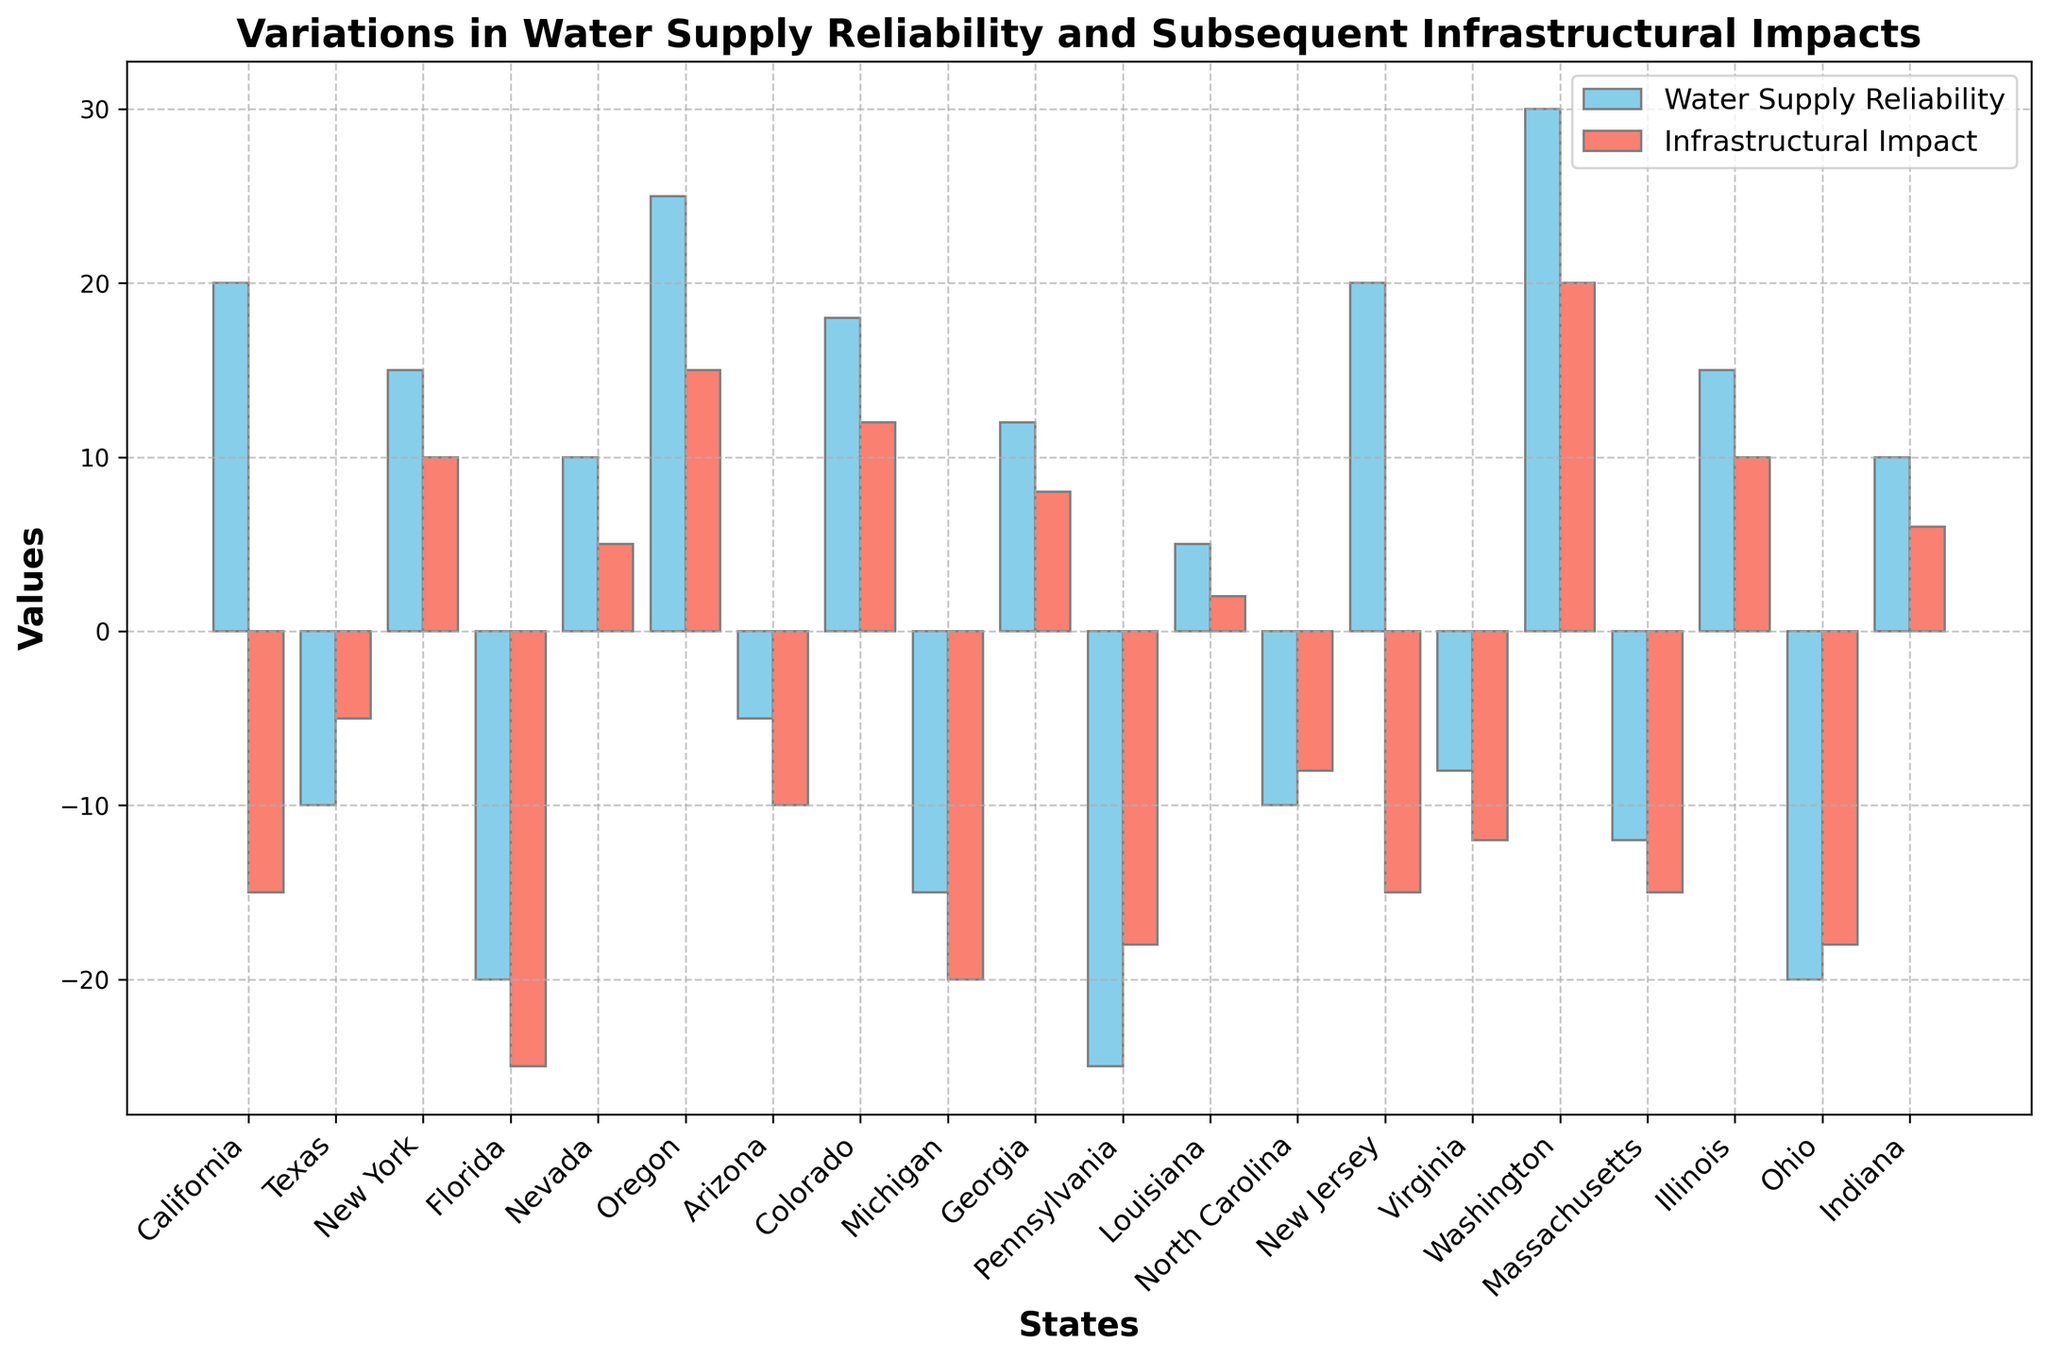What's the state with the highest positive water supply reliability? By visually inspecting the heights of the sky-blue bars, we see that Washington has the tallest positive bar, indicating the highest positive water supply reliability.
Answer: Washington Which two states have identical infrastructural impacts? By examining the heights and lengths of the salmon-colored bars, we notice that California and New Jersey both have identical values of -15.
Answer: California and New Jersey Compare the water supply reliability of Texas and Oregon. Which state has better reliability? Observing the sky-blue bars for Texas and Oregon, Texas' bar is below the baseline (negative value), whereas Oregon's bar is substantially above the baseline. Thus, Oregon has better reliability.
Answer: Oregon What is the difference in water supply reliability between Arizona and Michigan? Arizona's water supply reliability is -5 (below the baseline by 5 units), and Michigan's is -15 (below the baseline by 15 units). The difference is calculated as -5 - (-15), resulting in 10 units.
Answer: 10 units Which state has the worst infrastructural impact, and what is its value? By analyzing the lengths of the salmon-colored bars descending furthest below the baseline, Florida and Ohio both exhibit the longest bars corresponding to -25 and -18 respectively. Florida has the maximum negative value, thus the worst impact.
Answer: Florida, -25 What is the sum of water supply reliability for California and Washington? California's value is 20, and Washington's value is 30. Summing them up gives 20 + 30 = 50.
Answer: 50 Find the average infrastructural impact value across all states. Summing up all infrastructural impact values: -15 + (-5) + 10 + (-25) + 5 + 15 + (-10) + 12 + (-20) + 8 + (-18) + 2 + (-8) + (-15) + (-12) + 20 + (-15) + 10 + (-18) + 6 = -145. There are 20 states, so the average is -145 / 20 = -7.25.
Answer: -7.25 How many states have a negative water supply reliability value? Identifying the states with sky-blue bars below the baseline, we count Texas, Florida, Arizona, Michigan, Pennsylvania, North Carolina, Virginia, Massachusetts, Ohio, making a total of 9 states.
Answer: 9 states What is the infrastructural impact difference between Illinois and Indiana? Illinois has an impact value of 10, and Indiana has an impact of 6. The difference is 10 - 6 = 4.
Answer: 4 What is the total infrastructural impact for states with a positive water supply reliability? Summing the infrastructural impact values of states with positive water supply reliability (California: -15, New York: 10, Nevada: 5, Oregon: 15, Colorado: 12, Georgia: 8, New Jersey: -15, Washington: 20, Illinois: 10, Indiana: 6): -15 + 10 + 5 + 15 + 12 + 8 + (-15) + 20 + 10 + 6 = 56.
Answer: 56 